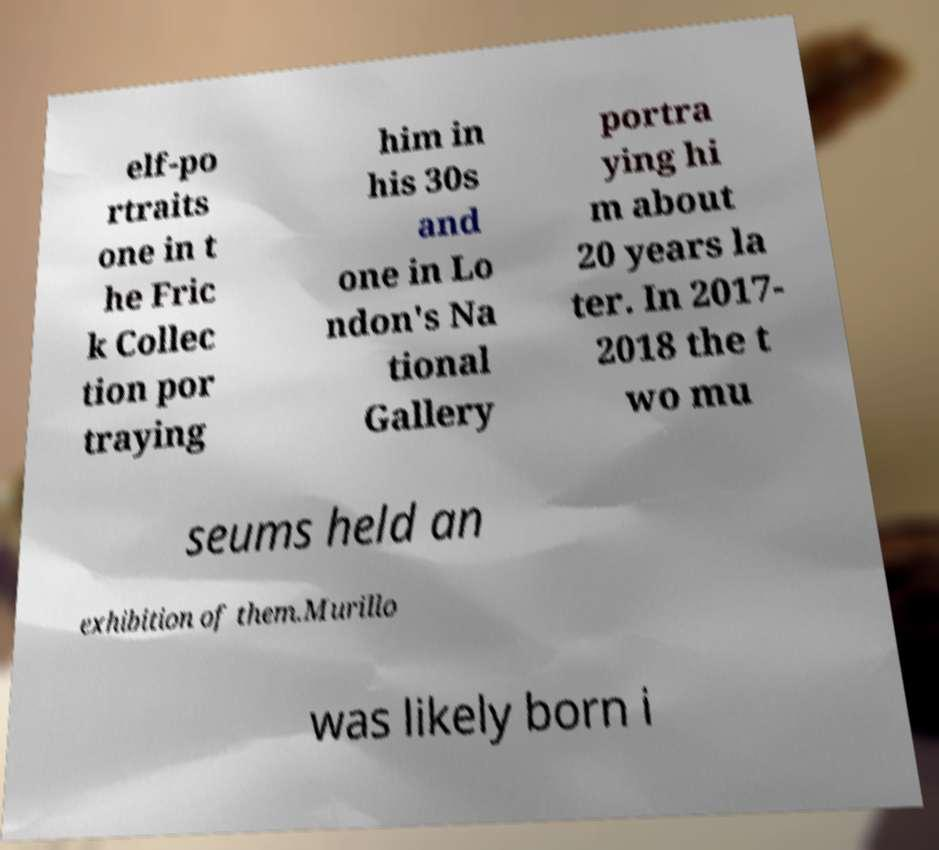Can you read and provide the text displayed in the image?This photo seems to have some interesting text. Can you extract and type it out for me? elf-po rtraits one in t he Fric k Collec tion por traying him in his 30s and one in Lo ndon's Na tional Gallery portra ying hi m about 20 years la ter. In 2017- 2018 the t wo mu seums held an exhibition of them.Murillo was likely born i 